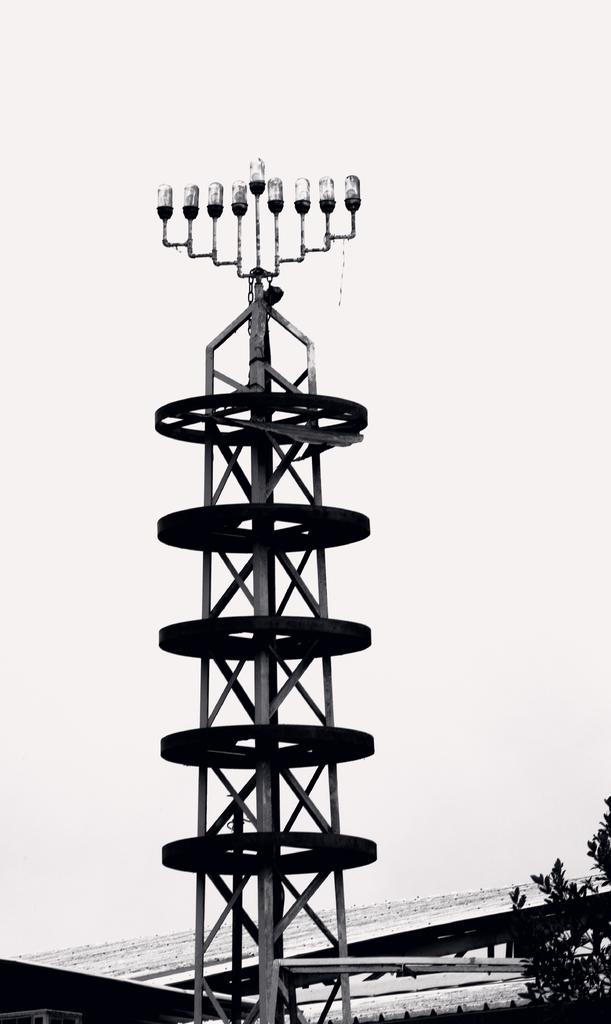What is the main structure visible in the image? There is a tower in the image. What is covering the top of the tower? There is a roof in the image. What type of natural element is present in the image? There is a tree in the image. What color scheme is used in the image? The image is black and white in color. How many rings can be seen on the tree in the image? There are no rings visible on the tree in the image, as it is a black and white image and rings are not visible without color. What type of sport is being played in the cemetery in the image? There is no cemetery or any sport being played in the image; it features a tower, roof, and tree in a black and white color scheme. 